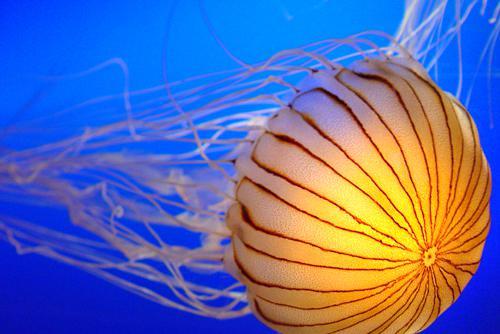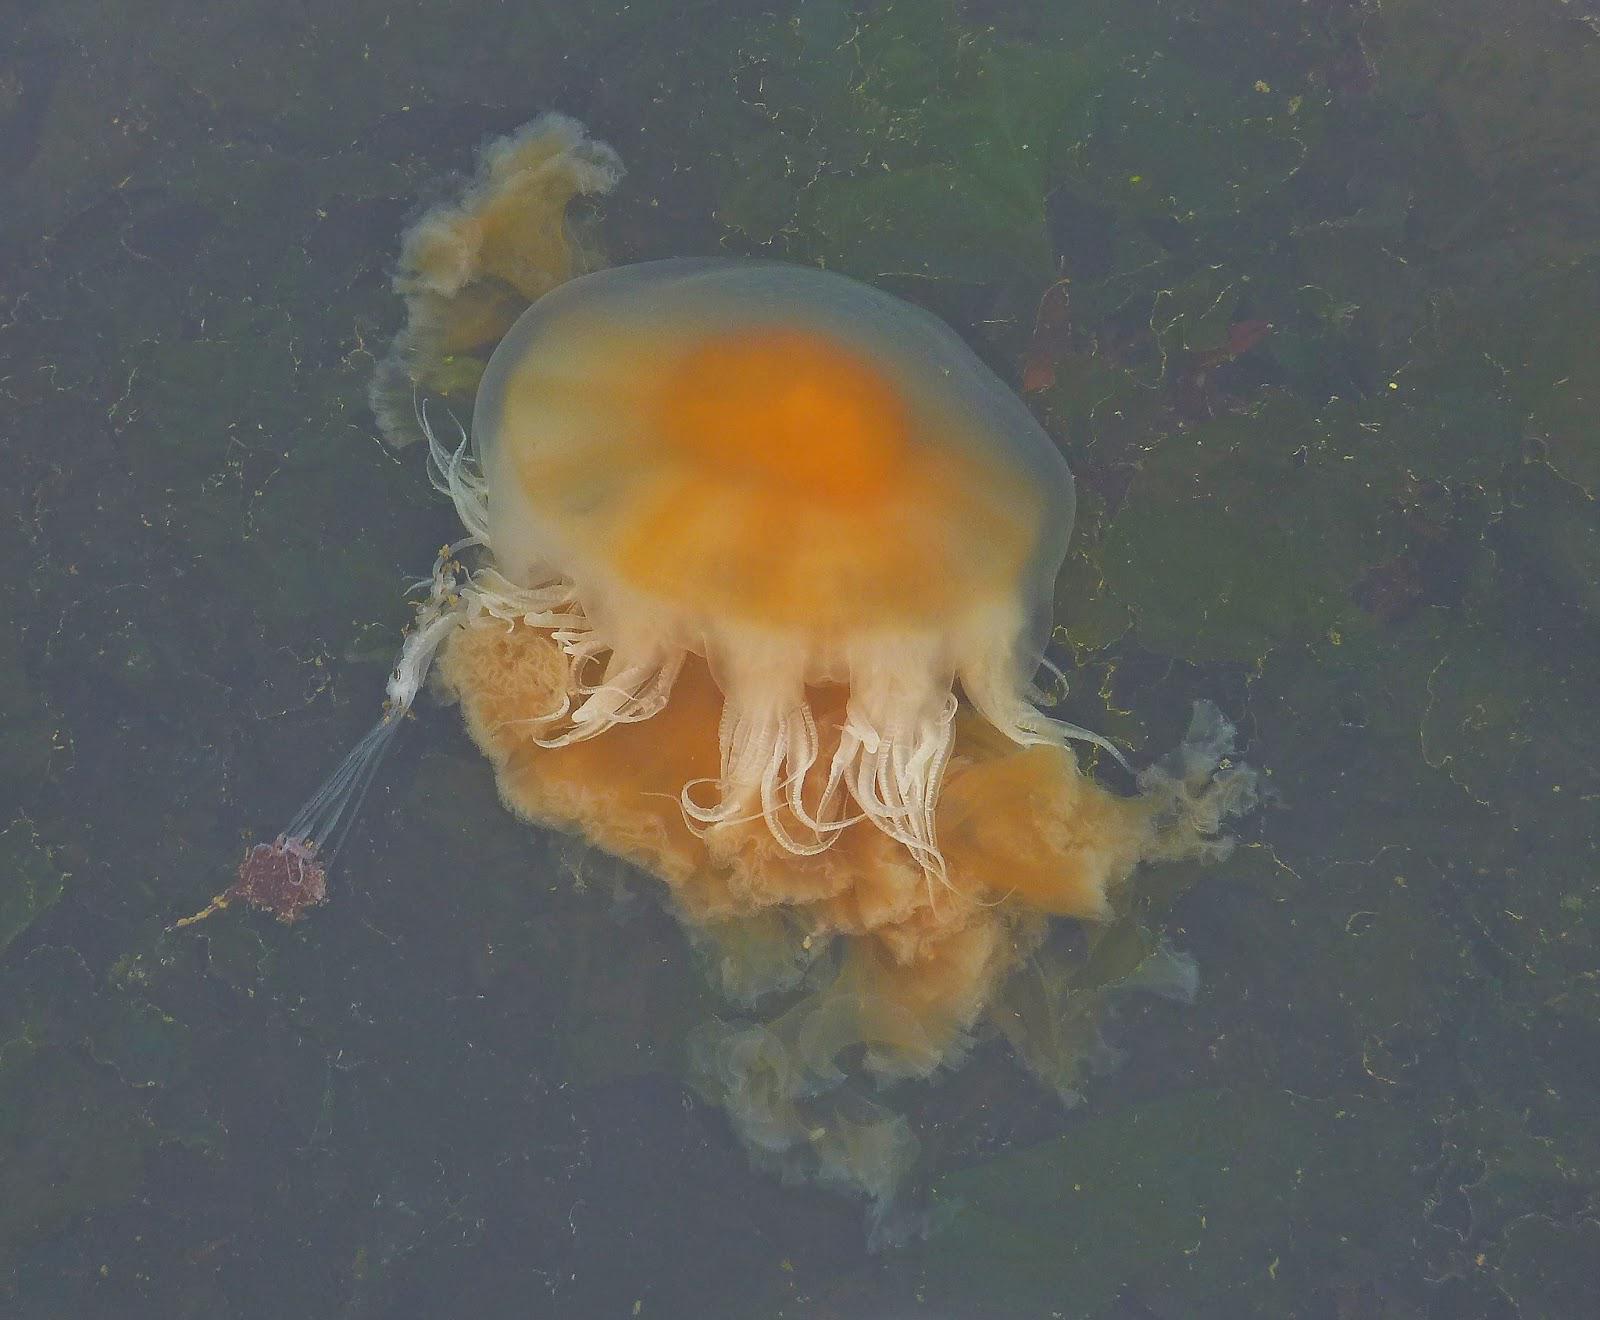The first image is the image on the left, the second image is the image on the right. Examine the images to the left and right. Is the description "the body of the jellyfish has dark stripes" accurate? Answer yes or no. Yes. The first image is the image on the left, the second image is the image on the right. Considering the images on both sides, is "At least one jellyfish has a striped top." valid? Answer yes or no. Yes. 